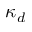Convert formula to latex. <formula><loc_0><loc_0><loc_500><loc_500>\kappa _ { d }</formula> 